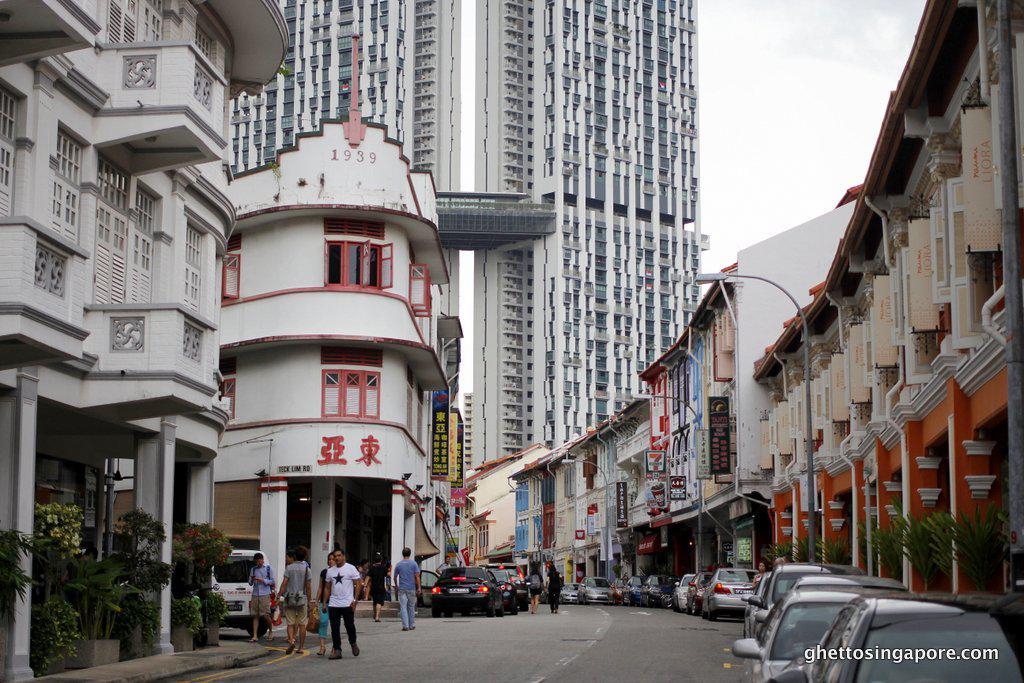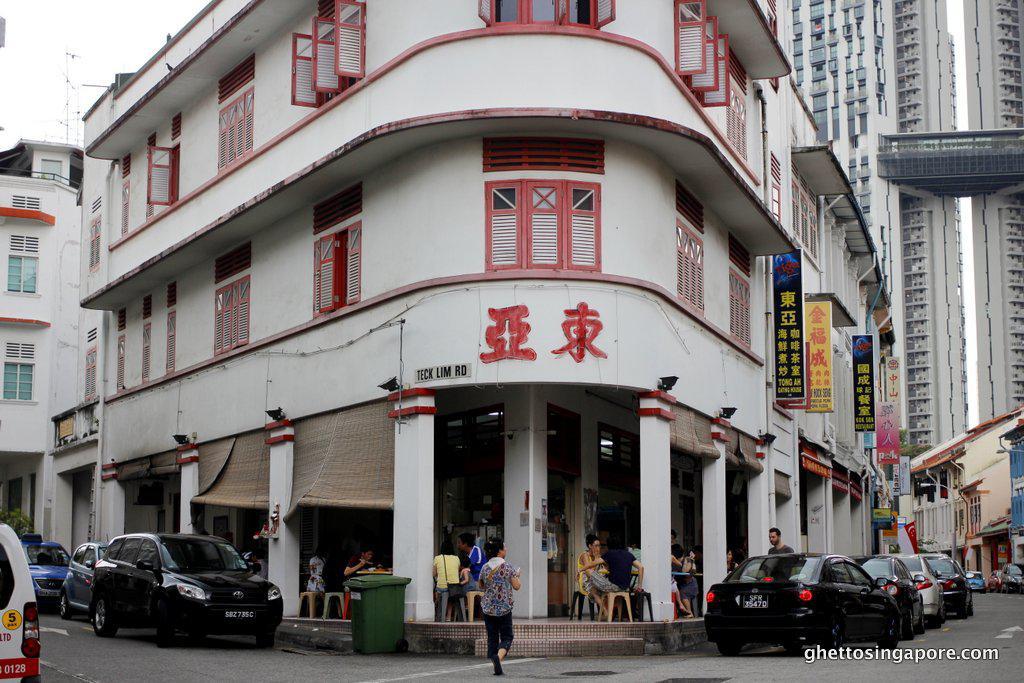The first image is the image on the left, the second image is the image on the right. Considering the images on both sides, is "There is a yellow sign above the door with asian lettering" valid? Answer yes or no. No. The first image is the image on the left, the second image is the image on the right. Assess this claim about the two images: "Left and right images show the same red-trimmed white building which curves around the corner with a row of columns.". Correct or not? Answer yes or no. Yes. 